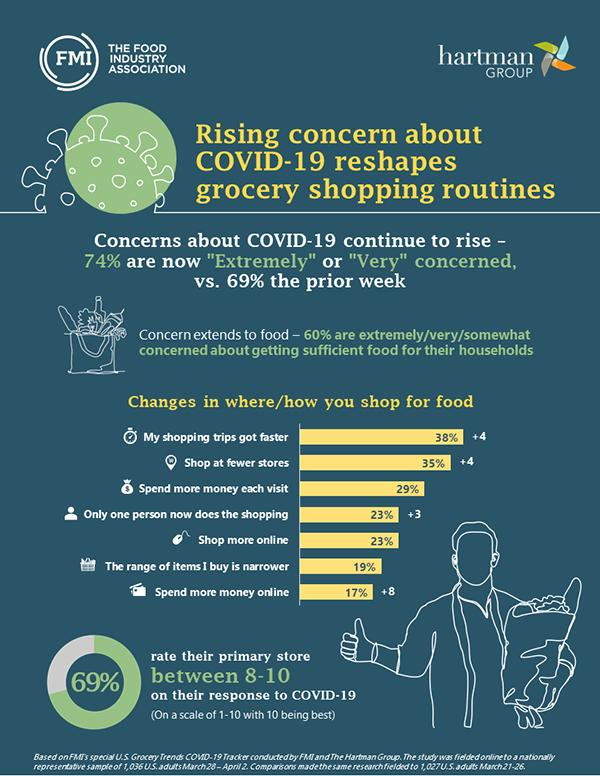Mention a couple of crucial points in this snapshot. According to a recent survey, 31% of people rate their primary store as below 8 on their response to the COVID-19 pandemic. According to the survey, 58% of people shop at fewer stores and prefer to shop more online. 